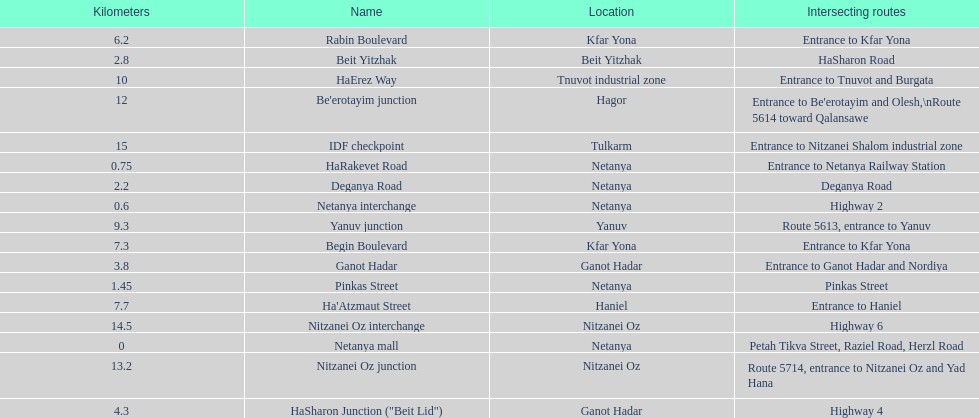Could you help me parse every detail presented in this table? {'header': ['Kilometers', 'Name', 'Location', 'Intersecting routes'], 'rows': [['6.2', 'Rabin Boulevard', 'Kfar Yona', 'Entrance to Kfar Yona'], ['2.8', 'Beit Yitzhak', 'Beit Yitzhak', 'HaSharon Road'], ['10', 'HaErez Way', 'Tnuvot industrial zone', 'Entrance to Tnuvot and Burgata'], ['12', "Be'erotayim junction", 'Hagor', "Entrance to Be'erotayim and Olesh,\\nRoute 5614 toward Qalansawe"], ['15', 'IDF checkpoint', 'Tulkarm', 'Entrance to Nitzanei Shalom industrial zone'], ['0.75', 'HaRakevet Road', 'Netanya', 'Entrance to Netanya Railway Station'], ['2.2', 'Deganya Road', 'Netanya', 'Deganya Road'], ['0.6', 'Netanya interchange', 'Netanya', 'Highway 2'], ['9.3', 'Yanuv junction', 'Yanuv', 'Route 5613, entrance to Yanuv'], ['7.3', 'Begin Boulevard', 'Kfar Yona', 'Entrance to Kfar Yona'], ['3.8', 'Ganot Hadar', 'Ganot Hadar', 'Entrance to Ganot Hadar and Nordiya'], ['1.45', 'Pinkas Street', 'Netanya', 'Pinkas Street'], ['7.7', "Ha'Atzmaut Street", 'Haniel', 'Entrance to Haniel'], ['14.5', 'Nitzanei Oz interchange', 'Nitzanei Oz', 'Highway 6'], ['0', 'Netanya mall', 'Netanya', 'Petah Tikva Street, Raziel Road, Herzl Road'], ['13.2', 'Nitzanei Oz junction', 'Nitzanei Oz', 'Route 5714, entrance to Nitzanei Oz and Yad Hana'], ['4.3', 'HaSharon Junction ("Beit Lid")', 'Ganot Hadar', 'Highway 4']]} Which portion has the same intersecting route as rabin boulevard? Begin Boulevard. 